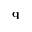<formula> <loc_0><loc_0><loc_500><loc_500>q</formula> 